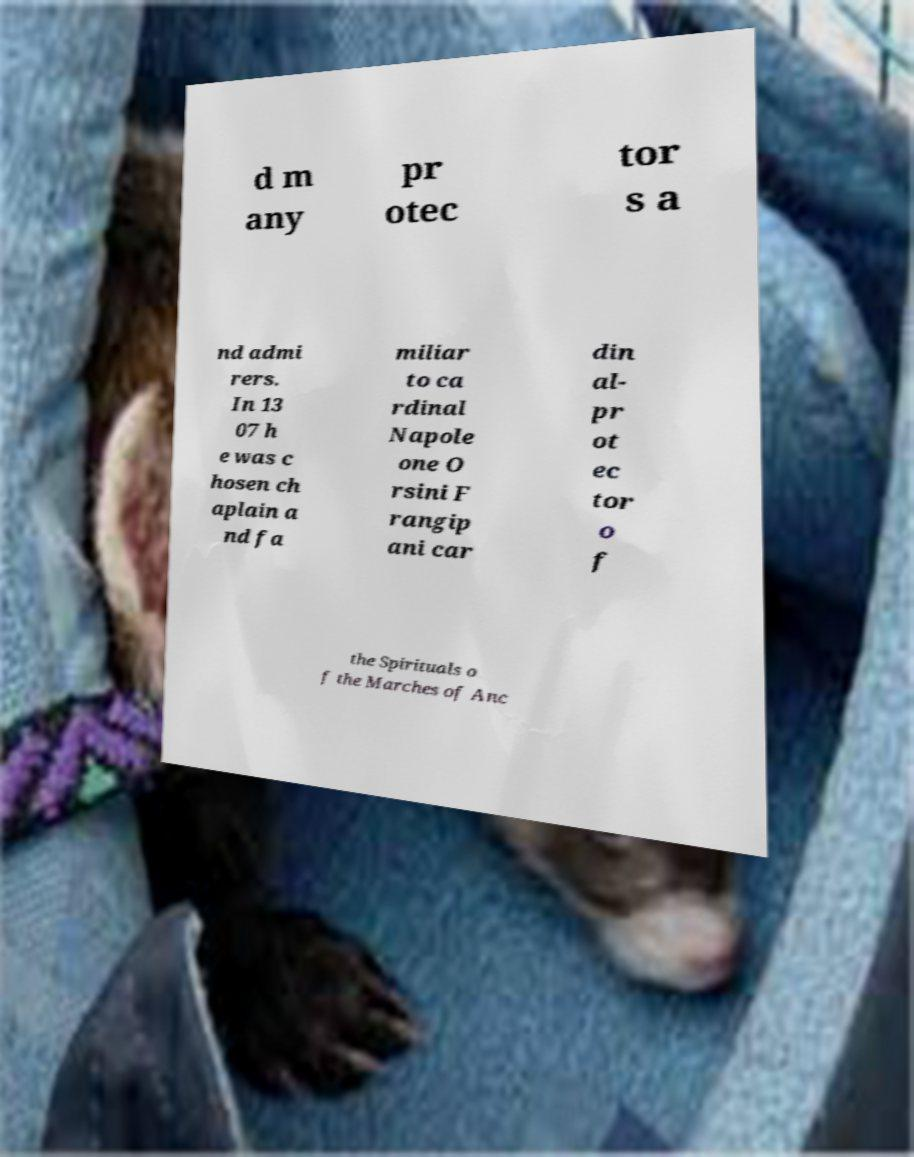For documentation purposes, I need the text within this image transcribed. Could you provide that? d m any pr otec tor s a nd admi rers. In 13 07 h e was c hosen ch aplain a nd fa miliar to ca rdinal Napole one O rsini F rangip ani car din al- pr ot ec tor o f the Spirituals o f the Marches of Anc 